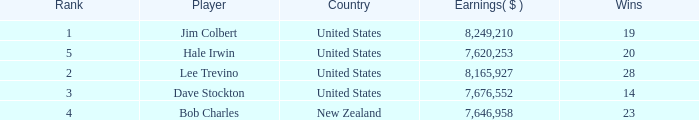How many average wins for players ranked below 2 with earnings greater than $7,676,552? None. 